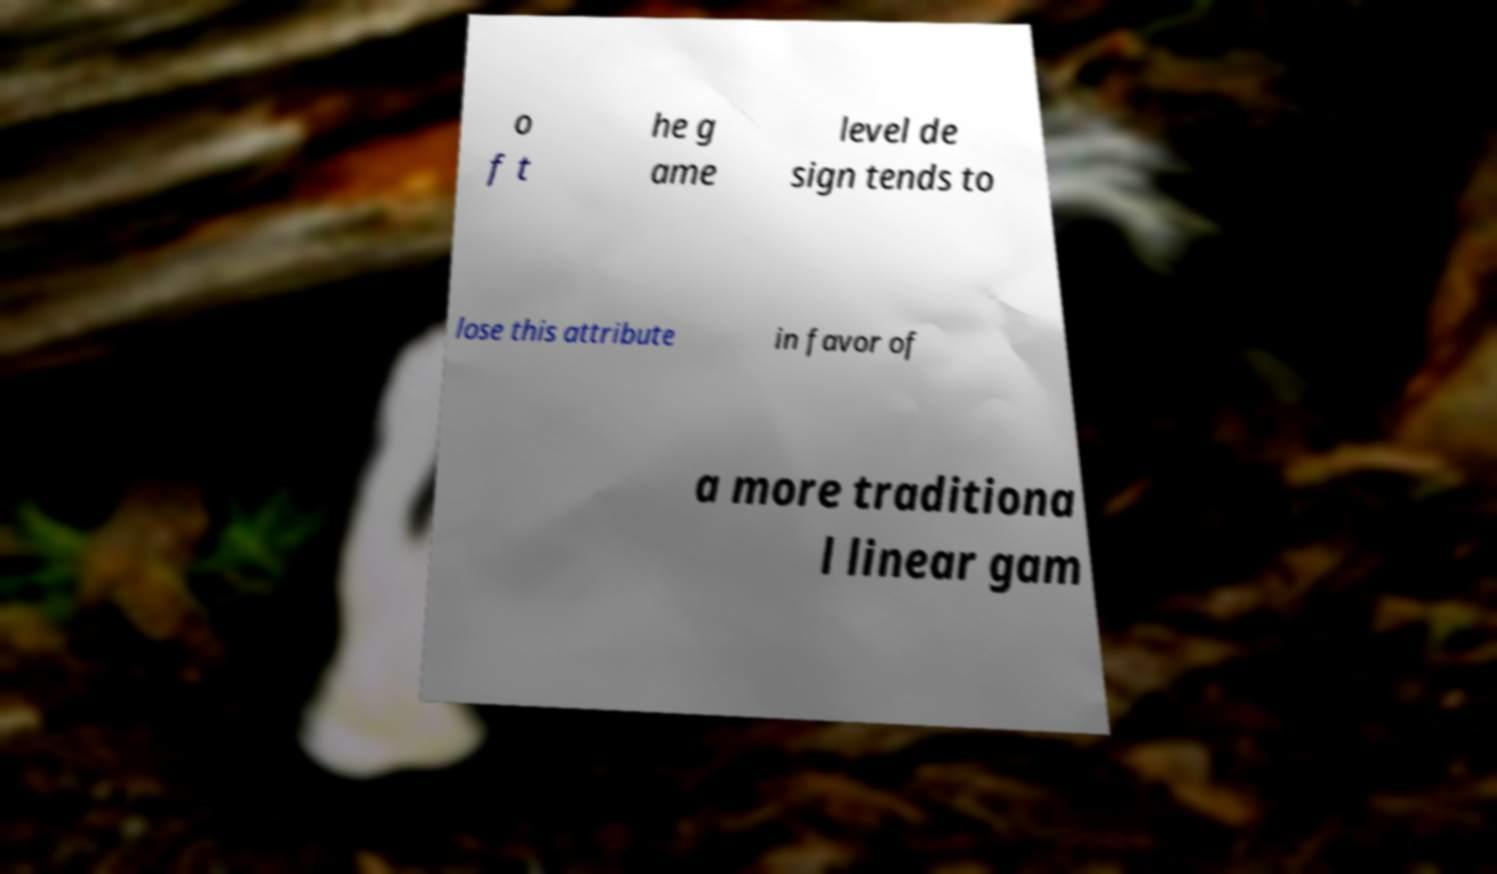What messages or text are displayed in this image? I need them in a readable, typed format. o f t he g ame level de sign tends to lose this attribute in favor of a more traditiona l linear gam 